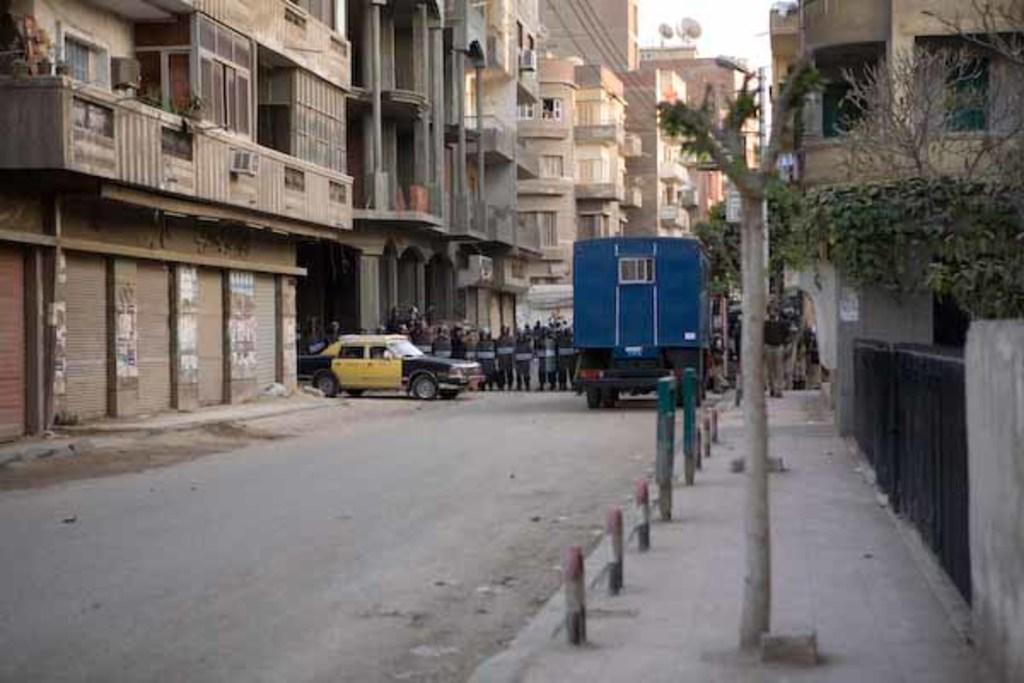Please provide a concise description of this image. In this picture I can see a group of people and two vehicles in the middle, there are buildings on either side of this image. On the right side there are trees, at the top I can see the sky. 